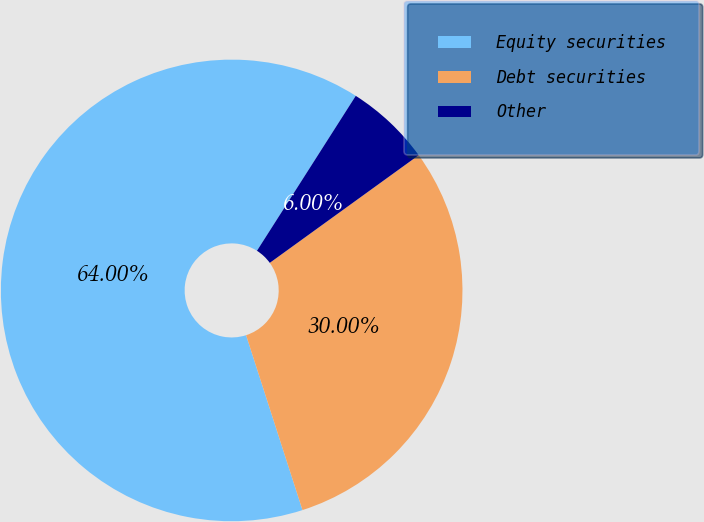Convert chart. <chart><loc_0><loc_0><loc_500><loc_500><pie_chart><fcel>Equity securities<fcel>Debt securities<fcel>Other<nl><fcel>64.0%<fcel>30.0%<fcel>6.0%<nl></chart> 